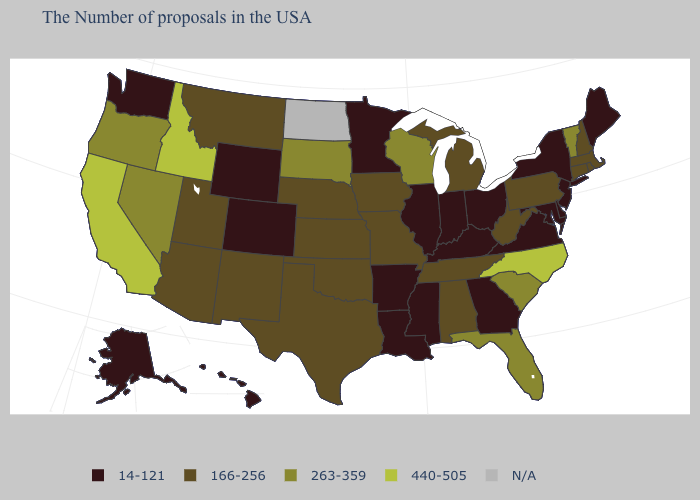What is the value of Wisconsin?
Answer briefly. 263-359. Name the states that have a value in the range 440-505?
Write a very short answer. North Carolina, Idaho, California. Does the map have missing data?
Give a very brief answer. Yes. Is the legend a continuous bar?
Quick response, please. No. Name the states that have a value in the range 166-256?
Be succinct. Massachusetts, Rhode Island, New Hampshire, Connecticut, Pennsylvania, West Virginia, Michigan, Alabama, Tennessee, Missouri, Iowa, Kansas, Nebraska, Oklahoma, Texas, New Mexico, Utah, Montana, Arizona. Name the states that have a value in the range 166-256?
Write a very short answer. Massachusetts, Rhode Island, New Hampshire, Connecticut, Pennsylvania, West Virginia, Michigan, Alabama, Tennessee, Missouri, Iowa, Kansas, Nebraska, Oklahoma, Texas, New Mexico, Utah, Montana, Arizona. What is the highest value in the MidWest ?
Write a very short answer. 263-359. What is the highest value in the Northeast ?
Concise answer only. 263-359. Name the states that have a value in the range 166-256?
Give a very brief answer. Massachusetts, Rhode Island, New Hampshire, Connecticut, Pennsylvania, West Virginia, Michigan, Alabama, Tennessee, Missouri, Iowa, Kansas, Nebraska, Oklahoma, Texas, New Mexico, Utah, Montana, Arizona. Name the states that have a value in the range N/A?
Answer briefly. North Dakota. Does New Jersey have the lowest value in the Northeast?
Concise answer only. Yes. Is the legend a continuous bar?
Be succinct. No. 